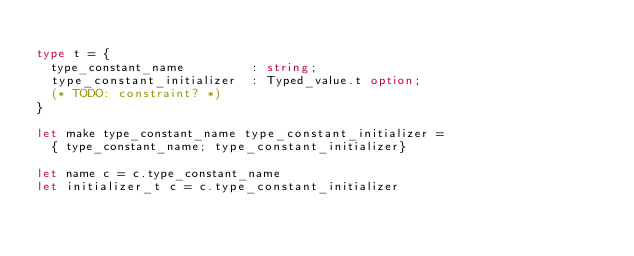Convert code to text. <code><loc_0><loc_0><loc_500><loc_500><_OCaml_>
type t = {
  type_constant_name         : string;
  type_constant_initializer  : Typed_value.t option;
  (* TODO: constraint? *)
}

let make type_constant_name type_constant_initializer =
  { type_constant_name; type_constant_initializer}

let name c = c.type_constant_name
let initializer_t c = c.type_constant_initializer
</code> 